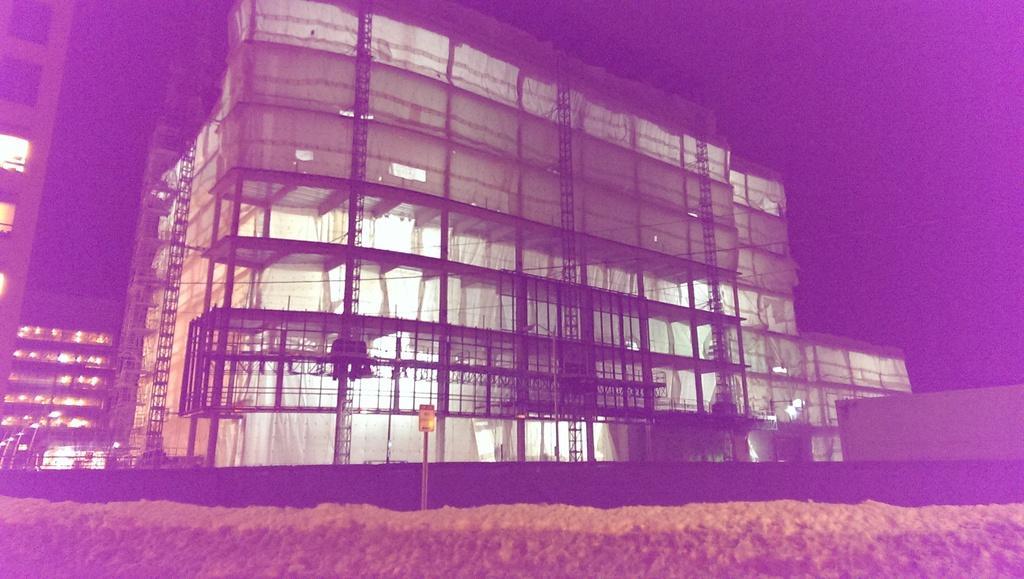How would you summarize this image in a sentence or two? In this image , in the middle there is a signal and near the signal there is a building and background is the sky. 